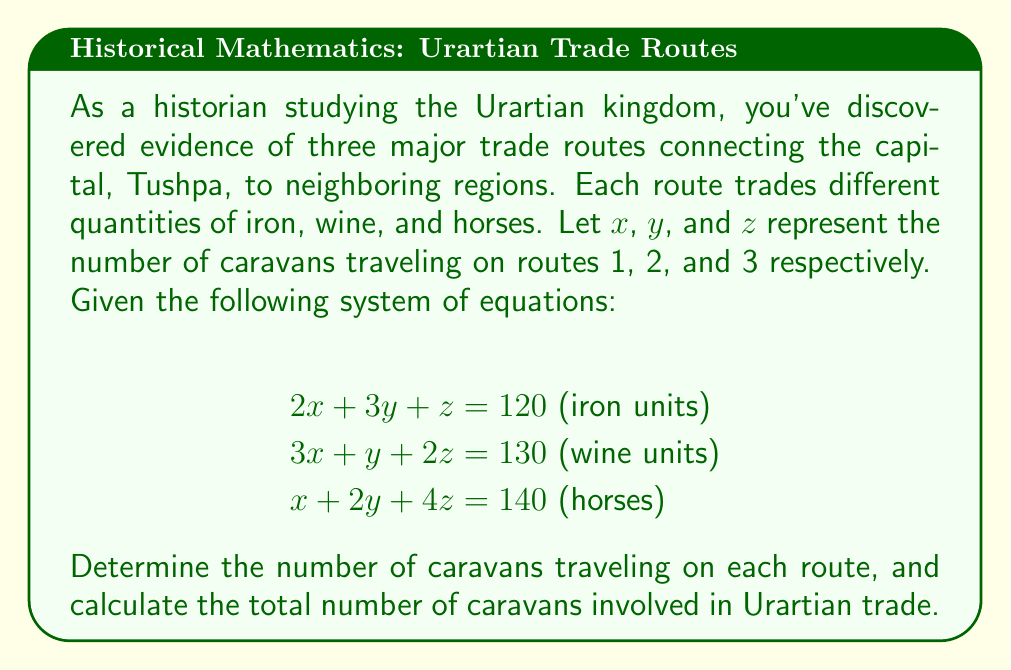Can you answer this question? To solve this system of linear equations, we'll use the elimination method:

1) Multiply the first equation by 3 and the second equation by -2:
   $$\begin{aligned}
   6x + 9y + 3z &= 360 \\
   -6x - 2y - 4z &= -260
   \end{aligned}$$

2) Add these equations to eliminate x:
   $$7y - z = 100 \quad \text{(Equation 4)}$$

3) Multiply the first equation by -1 and add it to the third equation:
   $$-y + 3z = 20 \quad \text{(Equation 5)}$$

4) Multiply Equation 4 by 3 and Equation 5 by 7:
   $$\begin{aligned}
   21y - 3z &= 300 \\
   -7y + 21z &= 140
   \end{aligned}$$

5) Add these equations:
   $$18z = 440$$
   $$z = \frac{440}{18} = \frac{220}{9} \approx 24.44$$

6) Substitute this value of z into Equation 5:
   $$-y + 3(\frac{220}{9}) = 20$$
   $$-y + \frac{220}{3} = 20$$
   $$-y = 20 - \frac{220}{3} = -\frac{160}{3}$$
   $$y = \frac{160}{3} \approx 53.33$$

7) Substitute y and z into the first equation:
   $$2x + 3(\frac{160}{3}) + \frac{220}{9} = 120$$
   $$2x + 160 + \frac{220}{9} = 120$$
   $$2x = 120 - 160 - \frac{220}{9} = -\frac{500}{9}$$
   $$x = -\frac{250}{9} \approx -27.78$$

Since we can't have negative caravans, we need to round up to the nearest whole number for a practical solution.
Answer: Route 1 (x): 0 caravans
Route 2 (y): 54 caravans
Route 3 (z): 25 caravans
Total number of caravans: 0 + 54 + 25 = 79 